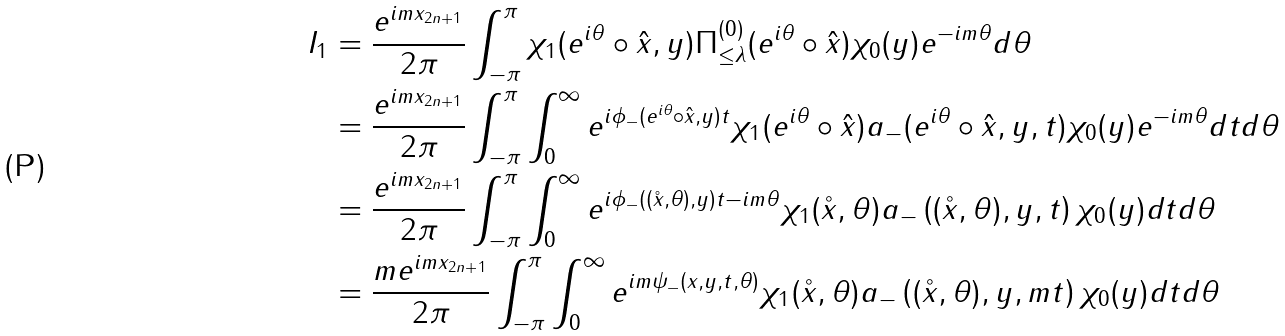<formula> <loc_0><loc_0><loc_500><loc_500>I _ { 1 } & = \frac { e ^ { i m x _ { 2 n + 1 } } } { 2 \pi } \int _ { - \pi } ^ { \pi } \chi _ { 1 } ( e ^ { i \theta } \circ \hat { x } , y ) \Pi ^ { ( 0 ) } _ { \leq \lambda } ( e ^ { i \theta } \circ \hat { x } ) \chi _ { 0 } ( y ) e ^ { - i m \theta } d \theta \\ & = \frac { e ^ { i m x _ { 2 n + 1 } } } { 2 \pi } \int _ { - \pi } ^ { \pi } \int _ { 0 } ^ { \infty } e ^ { i \phi _ { - } ( e ^ { i \theta } \circ \hat { x } , y ) t } \chi _ { 1 } ( e ^ { i \theta } \circ \hat { x } ) a _ { - } ( e ^ { i \theta } \circ \hat { x } , y , t ) \chi _ { 0 } ( y ) e ^ { - i m \theta } d t d \theta \\ & = \frac { e ^ { i m x _ { 2 n + 1 } } } { 2 \pi } \int _ { - \pi } ^ { \pi } \int _ { 0 } ^ { \infty } e ^ { i \phi _ { - } ( ( \mathring { x } , \theta ) , y ) t - i m \theta } \chi _ { 1 } ( \mathring { x } , \theta ) a _ { - } \left ( ( \mathring { x } , \theta ) , y , t \right ) \chi _ { 0 } ( y ) d t d \theta \\ & = \frac { m e ^ { i m x _ { 2 n + 1 } } } { 2 \pi } \int _ { - \pi } ^ { \pi } \int _ { 0 } ^ { \infty } e ^ { i m \psi _ { - } ( x , y , t , \theta ) } \chi _ { 1 } ( \mathring { x } , \theta ) a _ { - } \left ( ( \mathring { x } , \theta ) , y , m t \right ) \chi _ { 0 } ( y ) d t d \theta</formula> 